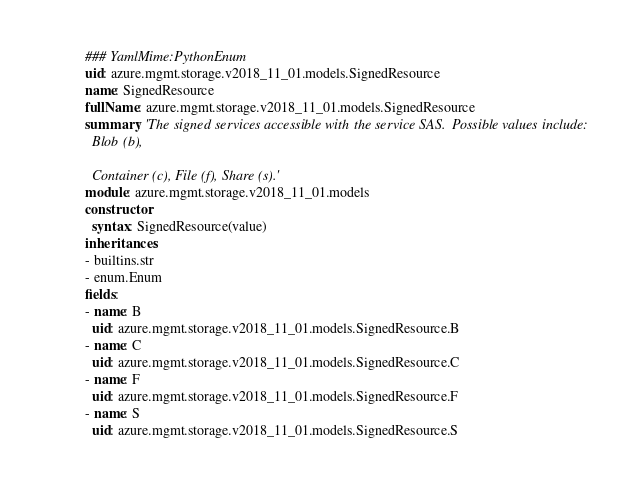Convert code to text. <code><loc_0><loc_0><loc_500><loc_500><_YAML_>### YamlMime:PythonEnum
uid: azure.mgmt.storage.v2018_11_01.models.SignedResource
name: SignedResource
fullName: azure.mgmt.storage.v2018_11_01.models.SignedResource
summary: 'The signed services accessible with the service SAS. Possible values include:
  Blob (b),

  Container (c), File (f), Share (s).'
module: azure.mgmt.storage.v2018_11_01.models
constructor:
  syntax: SignedResource(value)
inheritances:
- builtins.str
- enum.Enum
fields:
- name: B
  uid: azure.mgmt.storage.v2018_11_01.models.SignedResource.B
- name: C
  uid: azure.mgmt.storage.v2018_11_01.models.SignedResource.C
- name: F
  uid: azure.mgmt.storage.v2018_11_01.models.SignedResource.F
- name: S
  uid: azure.mgmt.storage.v2018_11_01.models.SignedResource.S
</code> 